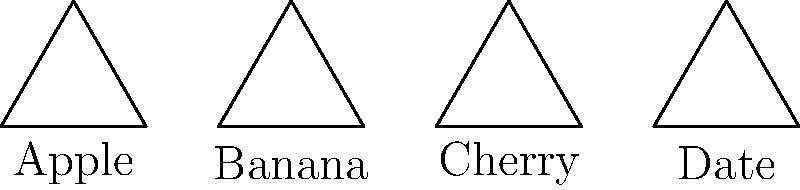As a language learning expert, you're designing a technology-enhanced vocabulary lesson. You've created a set of congruent equilateral triangles, each representing a different fruit vocabulary word. Which shape-word pair would you recommend the technology integration specialist use as an example to demonstrate the concept of congruence while reinforcing vocabulary learning? To answer this question, we need to consider both the mathematical concept of congruence and the pedagogical aspects of vocabulary learning. Let's break it down step-by-step:

1. Congruence in geometry: All the triangles in the image are congruent equilateral triangles. They have the same size and shape, just in different positions.

2. Vocabulary words: The triangles are labeled with four fruit vocabulary words: Apple, Banana, Cherry, and Date.

3. Educational value: The best choice would combine the mathematical concept with effective vocabulary learning.

4. Comparison strategy: In language learning, comparing and contrasting is an effective strategy. Choosing two words that are distinct but related can enhance learning.

5. Word choice: "Apple" and "Banana" are both common fruits that students are likely familiar with, making them good choices for an example.

6. Visual distinction: The triangles for "Apple" and "Banana" are adjacent, making it easy to visually compare them and demonstrate congruence.

7. Technology integration: Using interactive software, students could drag and overlay these shapes to visually confirm their congruence while reinforcing the vocabulary.

Given these considerations, the pair "Apple" and "Banana" would be the most effective choice. They are familiar words, visually distinct, and their triangles are positioned for easy comparison, making them ideal for demonstrating congruence while reinforcing vocabulary.
Answer: Apple and Banana 